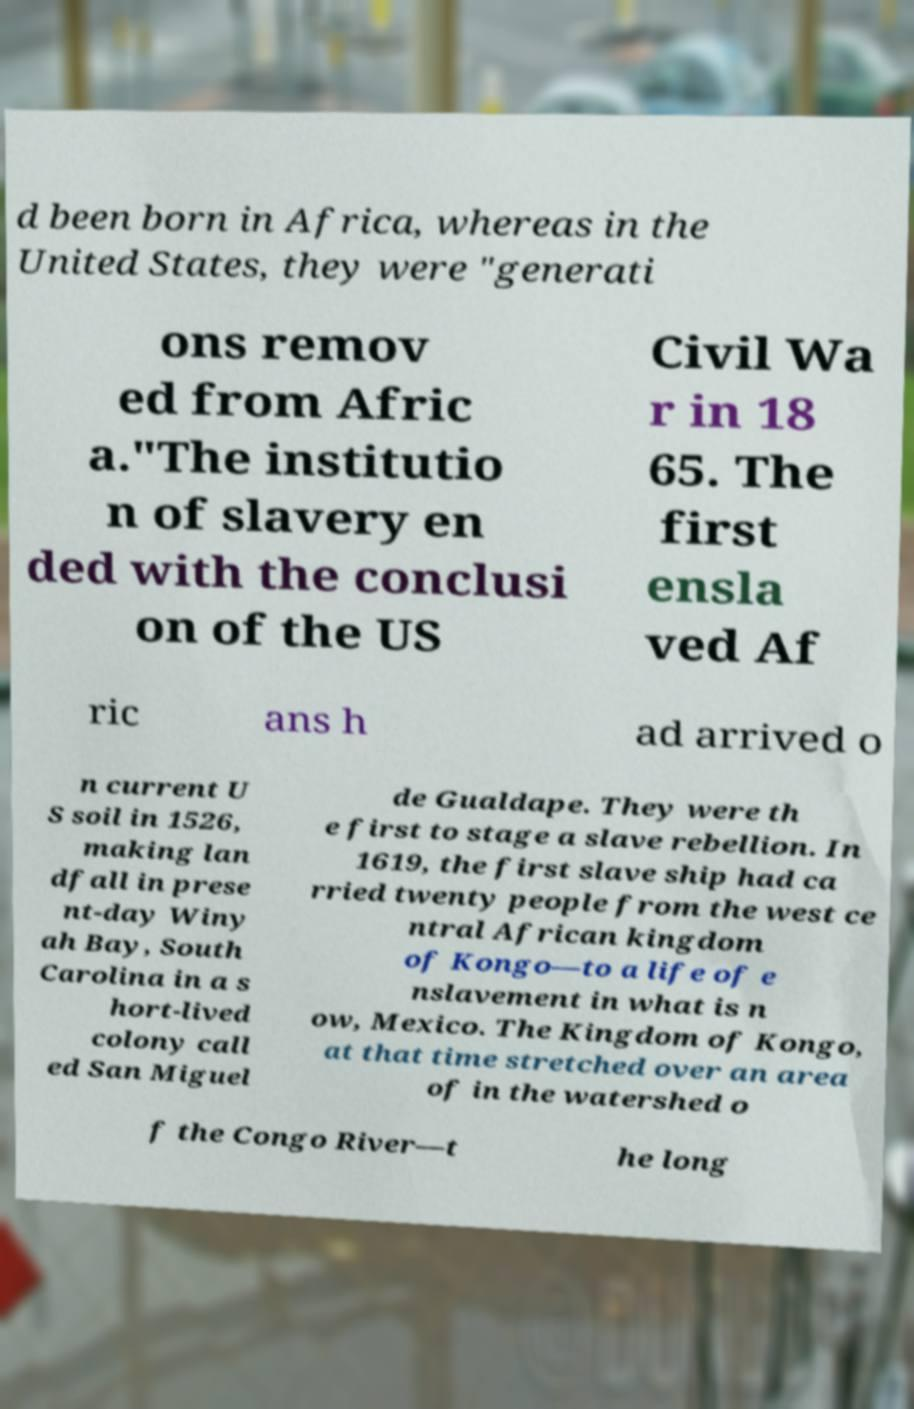Could you extract and type out the text from this image? d been born in Africa, whereas in the United States, they were "generati ons remov ed from Afric a."The institutio n of slavery en ded with the conclusi on of the US Civil Wa r in 18 65. The first ensla ved Af ric ans h ad arrived o n current U S soil in 1526, making lan dfall in prese nt-day Winy ah Bay, South Carolina in a s hort-lived colony call ed San Miguel de Gualdape. They were th e first to stage a slave rebellion. In 1619, the first slave ship had ca rried twenty people from the west ce ntral African kingdom of Kongo—to a life of e nslavement in what is n ow, Mexico. The Kingdom of Kongo, at that time stretched over an area of in the watershed o f the Congo River—t he long 